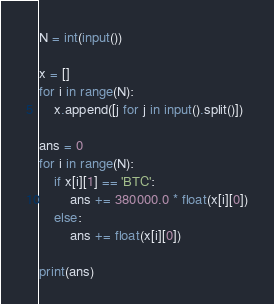Convert code to text. <code><loc_0><loc_0><loc_500><loc_500><_Python_>N = int(input())

x = []
for i in range(N):
    x.append([j for j in input().split()])

ans = 0
for i in range(N):
    if x[i][1] == 'BTC':
        ans += 380000.0 * float(x[i][0])
    else:
        ans += float(x[i][0])

print(ans)
</code> 